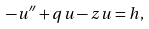Convert formula to latex. <formula><loc_0><loc_0><loc_500><loc_500>- u ^ { \prime \prime } + q u - z u = h ,</formula> 